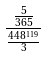Convert formula to latex. <formula><loc_0><loc_0><loc_500><loc_500>\frac { \frac { 5 } { 3 6 5 } } { \frac { 4 4 8 ^ { 1 1 9 } } { 3 } }</formula> 